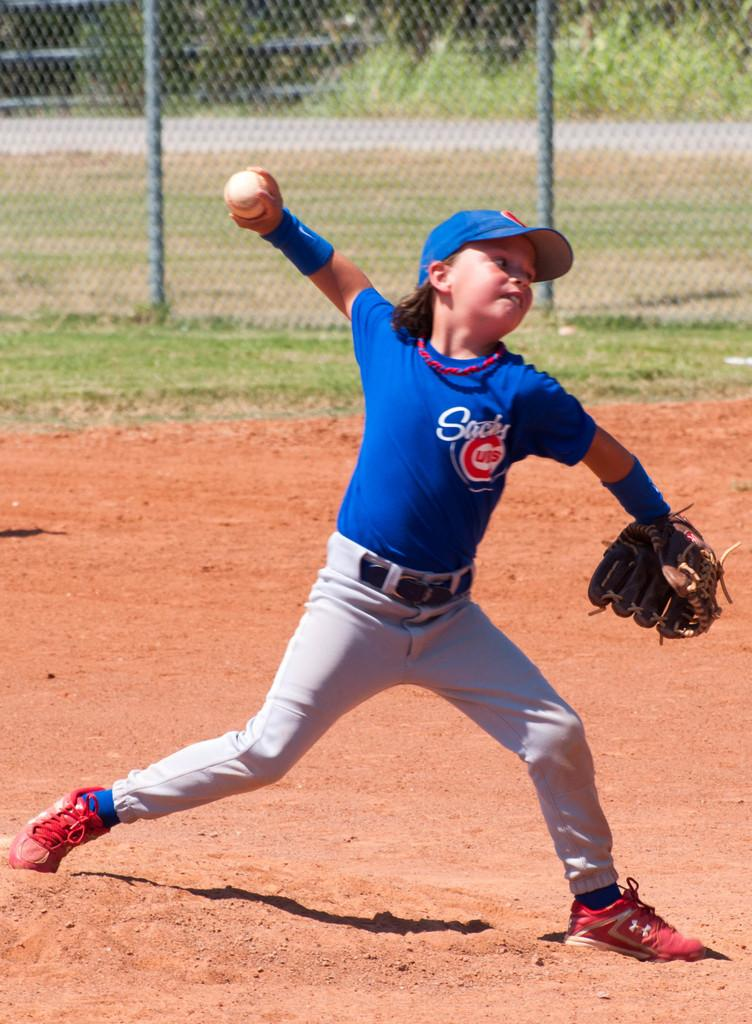<image>
Give a short and clear explanation of the subsequent image. A young baseball player wearing a jersey for the "Sachs Cubs". 